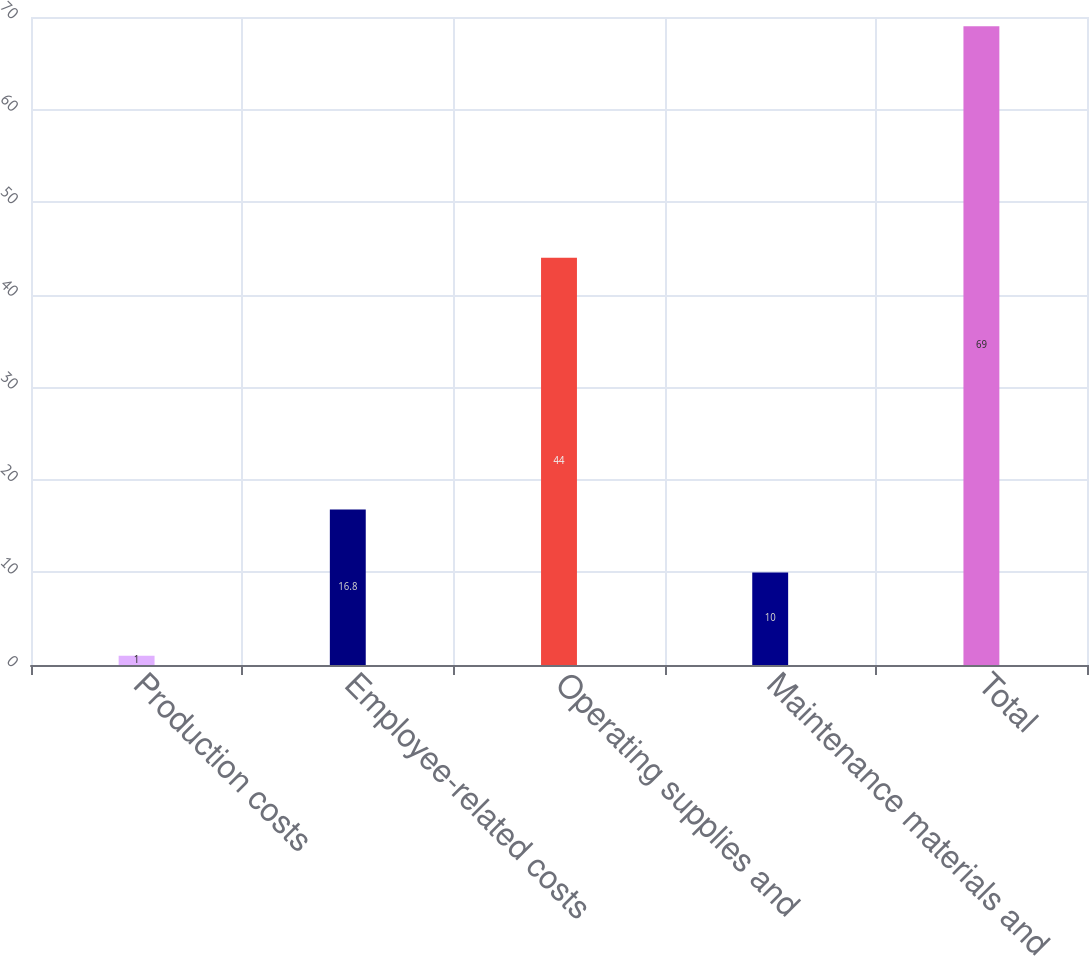Convert chart to OTSL. <chart><loc_0><loc_0><loc_500><loc_500><bar_chart><fcel>Production costs<fcel>Employee-related costs<fcel>Operating supplies and<fcel>Maintenance materials and<fcel>Total<nl><fcel>1<fcel>16.8<fcel>44<fcel>10<fcel>69<nl></chart> 